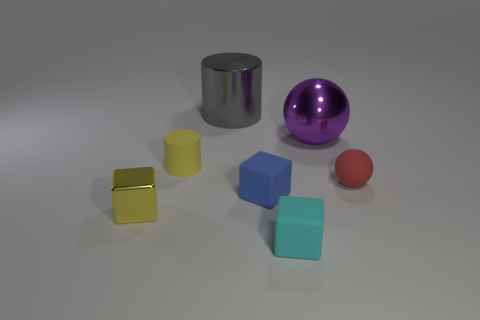Add 3 red metallic cylinders. How many objects exist? 10 Subtract all cubes. How many objects are left? 4 Subtract all blue rubber cubes. Subtract all yellow matte objects. How many objects are left? 5 Add 1 yellow cubes. How many yellow cubes are left? 2 Add 2 tiny cyan matte things. How many tiny cyan matte things exist? 3 Subtract 0 blue balls. How many objects are left? 7 